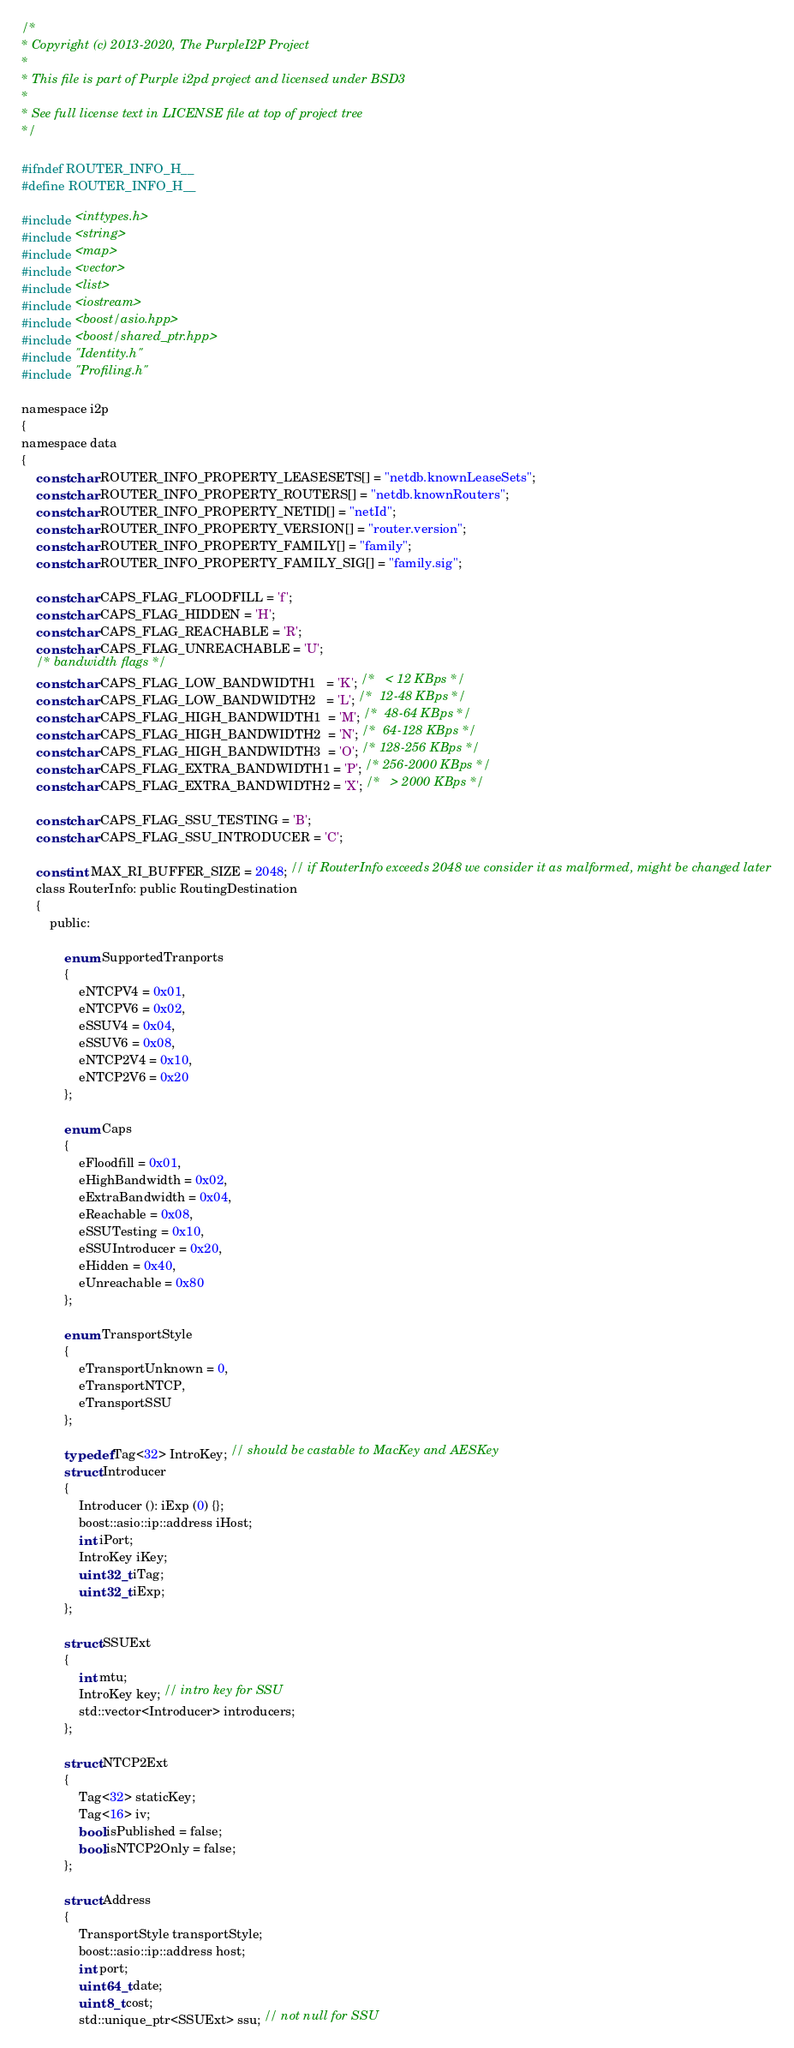Convert code to text. <code><loc_0><loc_0><loc_500><loc_500><_C_>/*
* Copyright (c) 2013-2020, The PurpleI2P Project
*
* This file is part of Purple i2pd project and licensed under BSD3
*
* See full license text in LICENSE file at top of project tree
*/

#ifndef ROUTER_INFO_H__
#define ROUTER_INFO_H__

#include <inttypes.h>
#include <string>
#include <map>
#include <vector>
#include <list>
#include <iostream>
#include <boost/asio.hpp>
#include <boost/shared_ptr.hpp>
#include "Identity.h"
#include "Profiling.h"

namespace i2p
{
namespace data
{
	const char ROUTER_INFO_PROPERTY_LEASESETS[] = "netdb.knownLeaseSets";
	const char ROUTER_INFO_PROPERTY_ROUTERS[] = "netdb.knownRouters";
	const char ROUTER_INFO_PROPERTY_NETID[] = "netId";
	const char ROUTER_INFO_PROPERTY_VERSION[] = "router.version";
	const char ROUTER_INFO_PROPERTY_FAMILY[] = "family";
	const char ROUTER_INFO_PROPERTY_FAMILY_SIG[] = "family.sig";

	const char CAPS_FLAG_FLOODFILL = 'f';
	const char CAPS_FLAG_HIDDEN = 'H';
	const char CAPS_FLAG_REACHABLE = 'R';
	const char CAPS_FLAG_UNREACHABLE = 'U';
	/* bandwidth flags */
	const char CAPS_FLAG_LOW_BANDWIDTH1   = 'K'; /*   < 12 KBps */
	const char CAPS_FLAG_LOW_BANDWIDTH2   = 'L'; /*  12-48 KBps */
	const char CAPS_FLAG_HIGH_BANDWIDTH1  = 'M'; /*  48-64 KBps */
	const char CAPS_FLAG_HIGH_BANDWIDTH2  = 'N'; /*  64-128 KBps */
	const char CAPS_FLAG_HIGH_BANDWIDTH3  = 'O'; /* 128-256 KBps */
	const char CAPS_FLAG_EXTRA_BANDWIDTH1 = 'P'; /* 256-2000 KBps */
	const char CAPS_FLAG_EXTRA_BANDWIDTH2 = 'X'; /*   > 2000 KBps */

	const char CAPS_FLAG_SSU_TESTING = 'B';
	const char CAPS_FLAG_SSU_INTRODUCER = 'C';

	const int MAX_RI_BUFFER_SIZE = 2048; // if RouterInfo exceeds 2048 we consider it as malformed, might be changed later
	class RouterInfo: public RoutingDestination
	{
		public:

			enum SupportedTranports
			{
				eNTCPV4 = 0x01,
				eNTCPV6 = 0x02,
				eSSUV4 = 0x04,
				eSSUV6 = 0x08,
				eNTCP2V4 = 0x10,
				eNTCP2V6 = 0x20
			};

			enum Caps
			{
				eFloodfill = 0x01,
				eHighBandwidth = 0x02,
				eExtraBandwidth = 0x04,
				eReachable = 0x08,
				eSSUTesting = 0x10,
				eSSUIntroducer = 0x20,
				eHidden = 0x40,
				eUnreachable = 0x80
			};

			enum TransportStyle
			{
				eTransportUnknown = 0,
				eTransportNTCP,
				eTransportSSU
			};

			typedef Tag<32> IntroKey; // should be castable to MacKey and AESKey
			struct Introducer
			{
				Introducer (): iExp (0) {};
				boost::asio::ip::address iHost;
				int iPort;
				IntroKey iKey;
				uint32_t iTag;
				uint32_t iExp;
			};

			struct SSUExt
			{
				int mtu;
				IntroKey key; // intro key for SSU
				std::vector<Introducer> introducers;
			};

			struct NTCP2Ext
			{
				Tag<32> staticKey;
				Tag<16> iv;
				bool isPublished = false;
				bool isNTCP2Only = false;
			};

			struct Address
			{
				TransportStyle transportStyle;
				boost::asio::ip::address host;
				int port;
				uint64_t date;
				uint8_t cost;
				std::unique_ptr<SSUExt> ssu; // not null for SSU</code> 